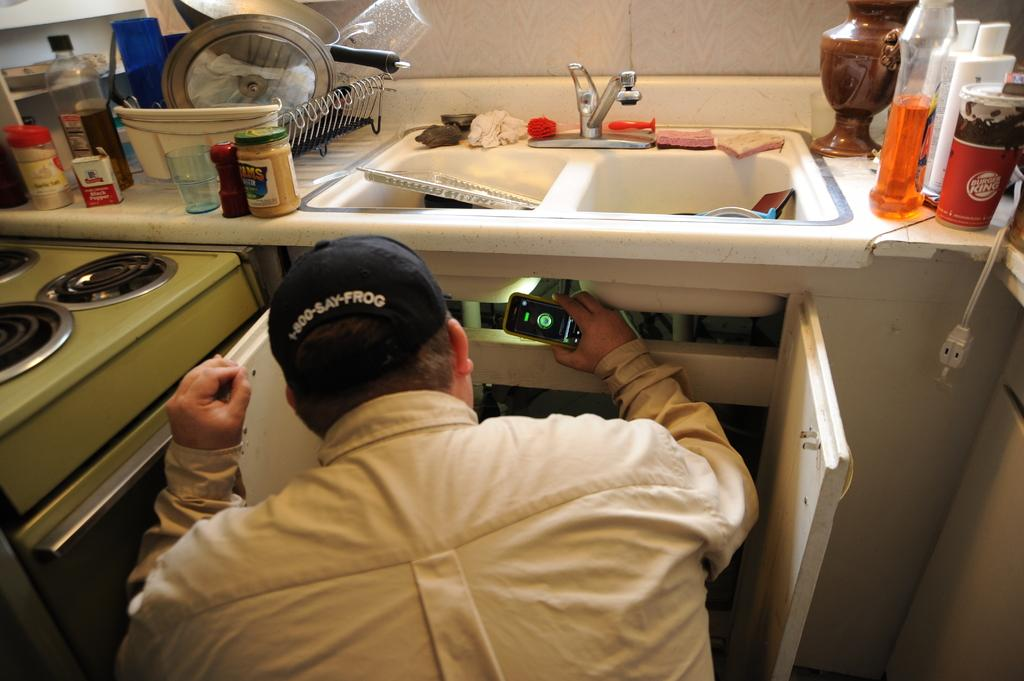<image>
Share a concise interpretation of the image provided. a man wearing a cap reading 1-800-SAY-FROG checking under a sink with his phone flashlight 